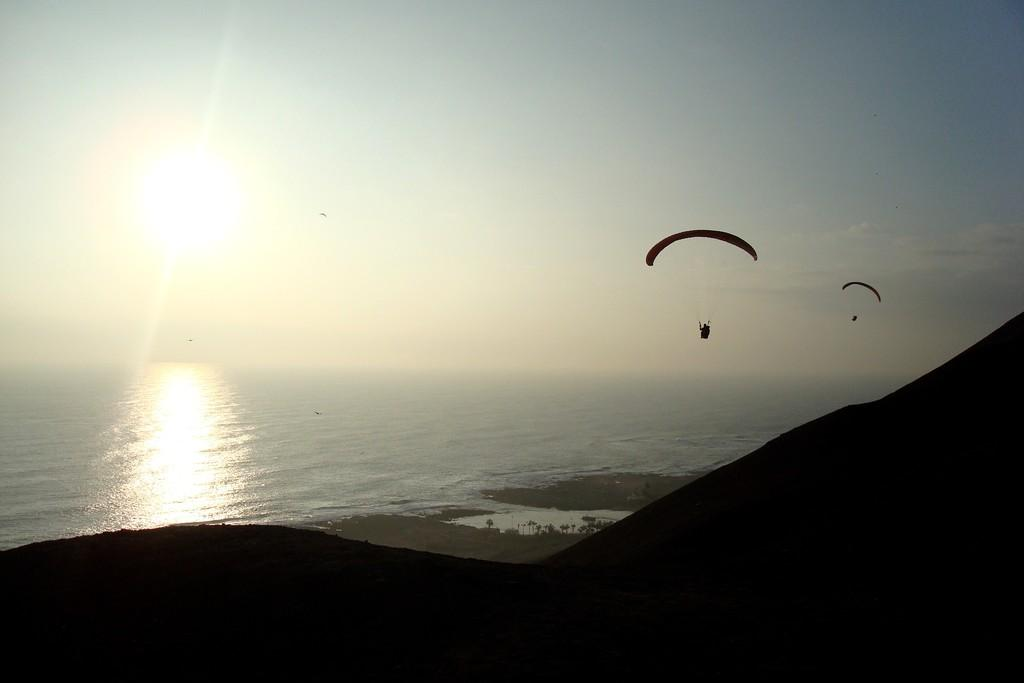What are the two people doing in the image? The two people are paragliding in the air. What is the landscape like in the image? There is water and a mountain visible in the image. What type of silk is being used by the fireman in the image? There is no fireman or silk present in the image; it features two paragliders flying in the air. 